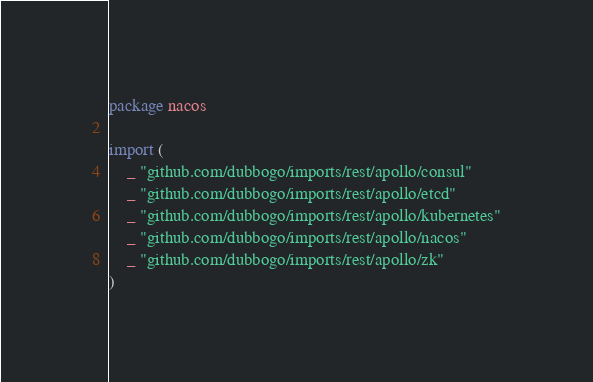Convert code to text. <code><loc_0><loc_0><loc_500><loc_500><_Go_>package nacos

import (
	_ "github.com/dubbogo/imports/rest/apollo/consul"
	_ "github.com/dubbogo/imports/rest/apollo/etcd"
	_ "github.com/dubbogo/imports/rest/apollo/kubernetes"
	_ "github.com/dubbogo/imports/rest/apollo/nacos"
	_ "github.com/dubbogo/imports/rest/apollo/zk"
)
</code> 